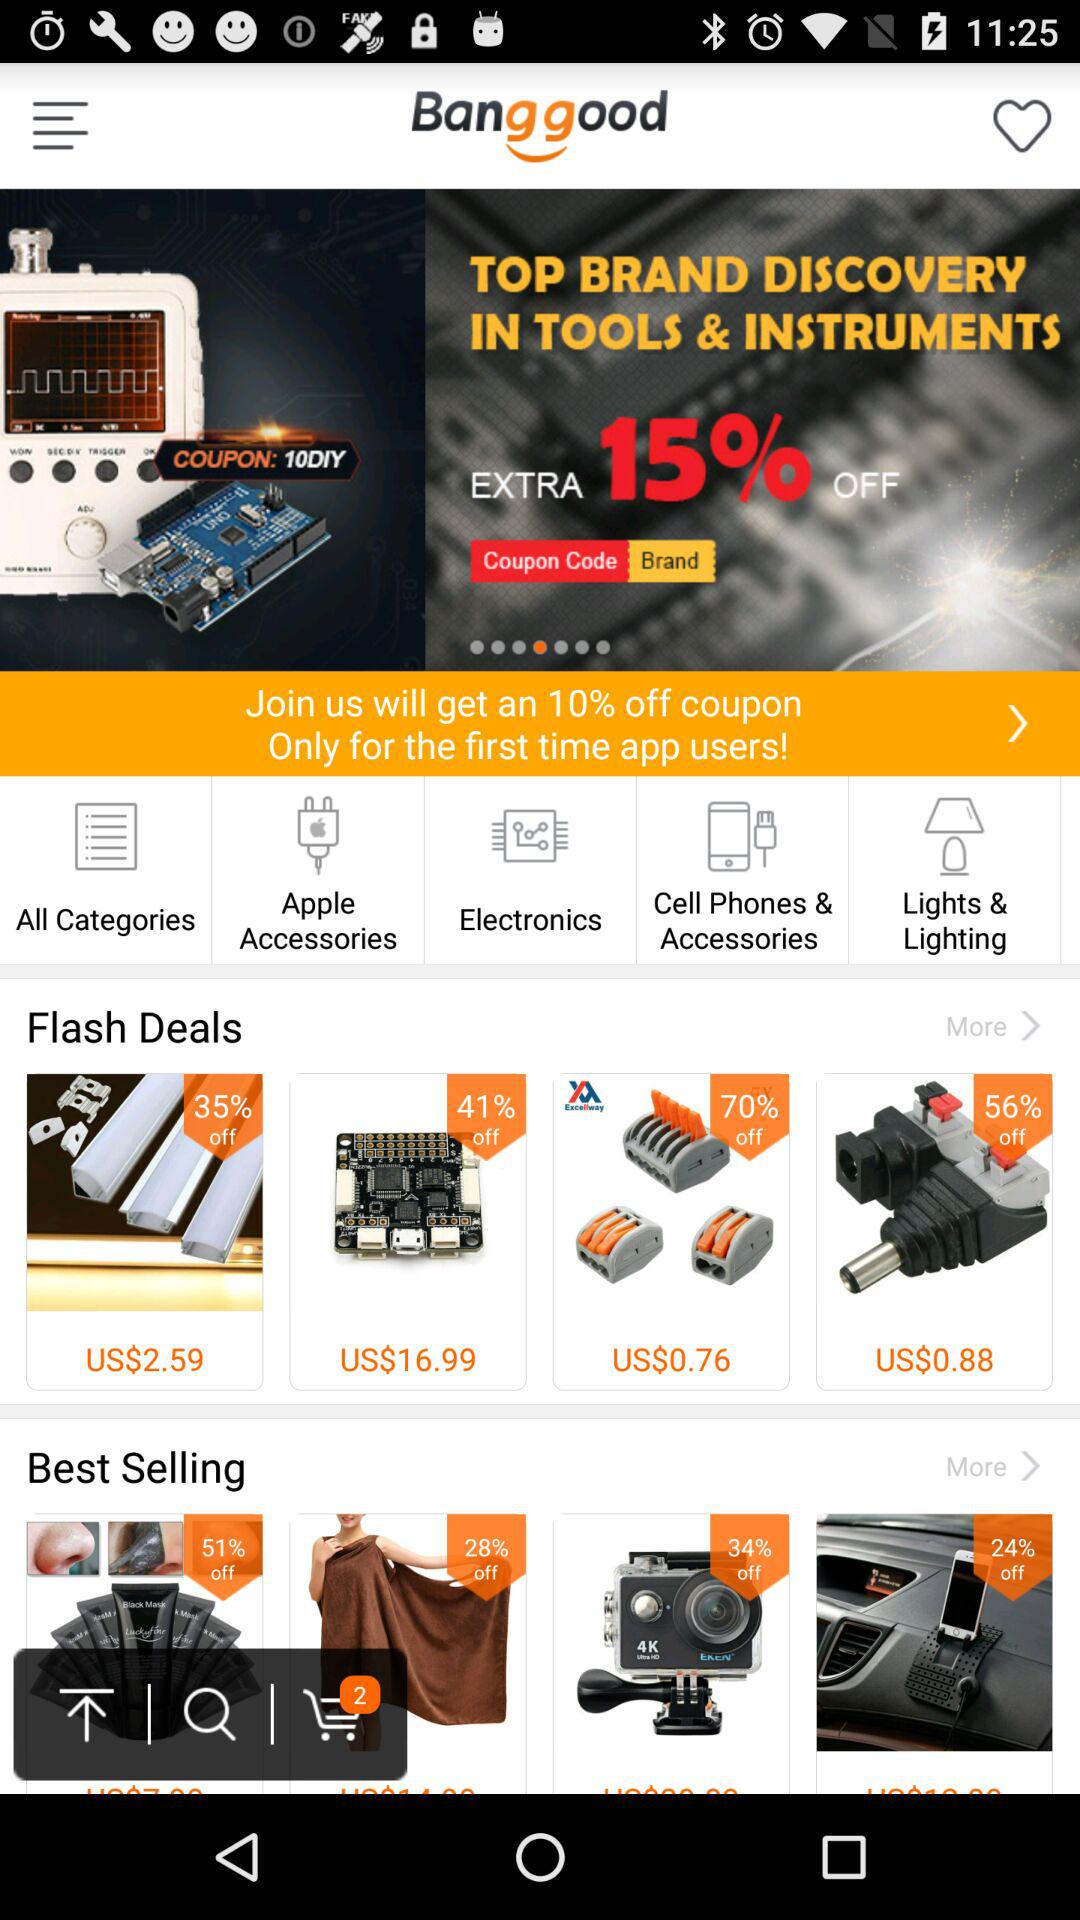How many best selling items are there?
Answer the question using a single word or phrase. 4 